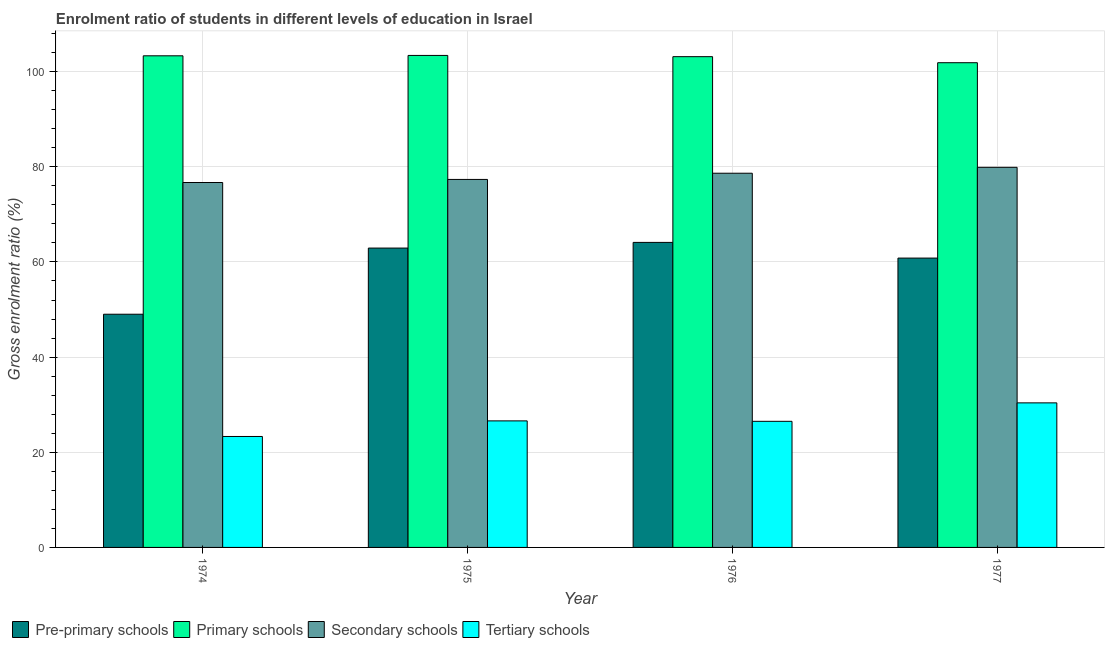Are the number of bars per tick equal to the number of legend labels?
Offer a very short reply. Yes. How many bars are there on the 2nd tick from the left?
Your answer should be compact. 4. How many bars are there on the 1st tick from the right?
Your answer should be very brief. 4. What is the label of the 4th group of bars from the left?
Give a very brief answer. 1977. What is the gross enrolment ratio in tertiary schools in 1975?
Your answer should be very brief. 26.6. Across all years, what is the maximum gross enrolment ratio in pre-primary schools?
Provide a short and direct response. 64.11. Across all years, what is the minimum gross enrolment ratio in secondary schools?
Your response must be concise. 76.7. In which year was the gross enrolment ratio in primary schools maximum?
Provide a short and direct response. 1975. In which year was the gross enrolment ratio in primary schools minimum?
Give a very brief answer. 1977. What is the total gross enrolment ratio in primary schools in the graph?
Your answer should be very brief. 411.76. What is the difference between the gross enrolment ratio in tertiary schools in 1976 and that in 1977?
Make the answer very short. -3.88. What is the difference between the gross enrolment ratio in pre-primary schools in 1976 and the gross enrolment ratio in tertiary schools in 1975?
Give a very brief answer. 1.19. What is the average gross enrolment ratio in tertiary schools per year?
Ensure brevity in your answer.  26.7. In the year 1977, what is the difference between the gross enrolment ratio in secondary schools and gross enrolment ratio in tertiary schools?
Make the answer very short. 0. What is the ratio of the gross enrolment ratio in pre-primary schools in 1974 to that in 1977?
Provide a succinct answer. 0.81. What is the difference between the highest and the second highest gross enrolment ratio in secondary schools?
Your answer should be compact. 1.24. What is the difference between the highest and the lowest gross enrolment ratio in primary schools?
Provide a succinct answer. 1.53. In how many years, is the gross enrolment ratio in primary schools greater than the average gross enrolment ratio in primary schools taken over all years?
Your response must be concise. 3. Is it the case that in every year, the sum of the gross enrolment ratio in tertiary schools and gross enrolment ratio in secondary schools is greater than the sum of gross enrolment ratio in pre-primary schools and gross enrolment ratio in primary schools?
Give a very brief answer. No. What does the 3rd bar from the left in 1974 represents?
Give a very brief answer. Secondary schools. What does the 4th bar from the right in 1977 represents?
Provide a short and direct response. Pre-primary schools. How many years are there in the graph?
Offer a terse response. 4. What is the difference between two consecutive major ticks on the Y-axis?
Offer a very short reply. 20. Are the values on the major ticks of Y-axis written in scientific E-notation?
Your response must be concise. No. Does the graph contain grids?
Keep it short and to the point. Yes. How many legend labels are there?
Your response must be concise. 4. What is the title of the graph?
Your response must be concise. Enrolment ratio of students in different levels of education in Israel. What is the label or title of the X-axis?
Make the answer very short. Year. What is the label or title of the Y-axis?
Make the answer very short. Gross enrolment ratio (%). What is the Gross enrolment ratio (%) in Pre-primary schools in 1974?
Give a very brief answer. 49.01. What is the Gross enrolment ratio (%) in Primary schools in 1974?
Your answer should be compact. 103.33. What is the Gross enrolment ratio (%) in Secondary schools in 1974?
Ensure brevity in your answer.  76.7. What is the Gross enrolment ratio (%) of Tertiary schools in 1974?
Offer a terse response. 23.32. What is the Gross enrolment ratio (%) in Pre-primary schools in 1975?
Provide a succinct answer. 62.92. What is the Gross enrolment ratio (%) of Primary schools in 1975?
Your answer should be very brief. 103.41. What is the Gross enrolment ratio (%) in Secondary schools in 1975?
Make the answer very short. 77.34. What is the Gross enrolment ratio (%) of Tertiary schools in 1975?
Your response must be concise. 26.6. What is the Gross enrolment ratio (%) in Pre-primary schools in 1976?
Your answer should be very brief. 64.11. What is the Gross enrolment ratio (%) of Primary schools in 1976?
Offer a terse response. 103.15. What is the Gross enrolment ratio (%) in Secondary schools in 1976?
Offer a very short reply. 78.65. What is the Gross enrolment ratio (%) in Tertiary schools in 1976?
Give a very brief answer. 26.5. What is the Gross enrolment ratio (%) in Pre-primary schools in 1977?
Ensure brevity in your answer.  60.81. What is the Gross enrolment ratio (%) of Primary schools in 1977?
Ensure brevity in your answer.  101.88. What is the Gross enrolment ratio (%) in Secondary schools in 1977?
Provide a short and direct response. 79.89. What is the Gross enrolment ratio (%) in Tertiary schools in 1977?
Provide a short and direct response. 30.38. Across all years, what is the maximum Gross enrolment ratio (%) of Pre-primary schools?
Ensure brevity in your answer.  64.11. Across all years, what is the maximum Gross enrolment ratio (%) in Primary schools?
Keep it short and to the point. 103.41. Across all years, what is the maximum Gross enrolment ratio (%) in Secondary schools?
Offer a very short reply. 79.89. Across all years, what is the maximum Gross enrolment ratio (%) of Tertiary schools?
Your answer should be compact. 30.38. Across all years, what is the minimum Gross enrolment ratio (%) of Pre-primary schools?
Your answer should be compact. 49.01. Across all years, what is the minimum Gross enrolment ratio (%) in Primary schools?
Keep it short and to the point. 101.88. Across all years, what is the minimum Gross enrolment ratio (%) in Secondary schools?
Provide a succinct answer. 76.7. Across all years, what is the minimum Gross enrolment ratio (%) of Tertiary schools?
Your answer should be very brief. 23.32. What is the total Gross enrolment ratio (%) of Pre-primary schools in the graph?
Keep it short and to the point. 236.86. What is the total Gross enrolment ratio (%) of Primary schools in the graph?
Make the answer very short. 411.76. What is the total Gross enrolment ratio (%) of Secondary schools in the graph?
Keep it short and to the point. 312.58. What is the total Gross enrolment ratio (%) of Tertiary schools in the graph?
Your response must be concise. 106.8. What is the difference between the Gross enrolment ratio (%) of Pre-primary schools in 1974 and that in 1975?
Your response must be concise. -13.91. What is the difference between the Gross enrolment ratio (%) in Primary schools in 1974 and that in 1975?
Offer a very short reply. -0.08. What is the difference between the Gross enrolment ratio (%) of Secondary schools in 1974 and that in 1975?
Provide a succinct answer. -0.65. What is the difference between the Gross enrolment ratio (%) of Tertiary schools in 1974 and that in 1975?
Your response must be concise. -3.28. What is the difference between the Gross enrolment ratio (%) in Pre-primary schools in 1974 and that in 1976?
Ensure brevity in your answer.  -15.1. What is the difference between the Gross enrolment ratio (%) in Primary schools in 1974 and that in 1976?
Your answer should be compact. 0.18. What is the difference between the Gross enrolment ratio (%) of Secondary schools in 1974 and that in 1976?
Give a very brief answer. -1.95. What is the difference between the Gross enrolment ratio (%) of Tertiary schools in 1974 and that in 1976?
Offer a terse response. -3.18. What is the difference between the Gross enrolment ratio (%) in Pre-primary schools in 1974 and that in 1977?
Ensure brevity in your answer.  -11.8. What is the difference between the Gross enrolment ratio (%) of Primary schools in 1974 and that in 1977?
Give a very brief answer. 1.45. What is the difference between the Gross enrolment ratio (%) in Secondary schools in 1974 and that in 1977?
Offer a terse response. -3.19. What is the difference between the Gross enrolment ratio (%) of Tertiary schools in 1974 and that in 1977?
Make the answer very short. -7.06. What is the difference between the Gross enrolment ratio (%) in Pre-primary schools in 1975 and that in 1976?
Offer a terse response. -1.19. What is the difference between the Gross enrolment ratio (%) of Primary schools in 1975 and that in 1976?
Give a very brief answer. 0.26. What is the difference between the Gross enrolment ratio (%) of Secondary schools in 1975 and that in 1976?
Ensure brevity in your answer.  -1.3. What is the difference between the Gross enrolment ratio (%) of Tertiary schools in 1975 and that in 1976?
Keep it short and to the point. 0.09. What is the difference between the Gross enrolment ratio (%) in Pre-primary schools in 1975 and that in 1977?
Your response must be concise. 2.11. What is the difference between the Gross enrolment ratio (%) of Primary schools in 1975 and that in 1977?
Keep it short and to the point. 1.53. What is the difference between the Gross enrolment ratio (%) of Secondary schools in 1975 and that in 1977?
Provide a succinct answer. -2.55. What is the difference between the Gross enrolment ratio (%) of Tertiary schools in 1975 and that in 1977?
Offer a terse response. -3.79. What is the difference between the Gross enrolment ratio (%) of Pre-primary schools in 1976 and that in 1977?
Offer a terse response. 3.3. What is the difference between the Gross enrolment ratio (%) of Primary schools in 1976 and that in 1977?
Offer a terse response. 1.27. What is the difference between the Gross enrolment ratio (%) of Secondary schools in 1976 and that in 1977?
Your answer should be compact. -1.24. What is the difference between the Gross enrolment ratio (%) in Tertiary schools in 1976 and that in 1977?
Provide a short and direct response. -3.88. What is the difference between the Gross enrolment ratio (%) of Pre-primary schools in 1974 and the Gross enrolment ratio (%) of Primary schools in 1975?
Offer a terse response. -54.4. What is the difference between the Gross enrolment ratio (%) of Pre-primary schools in 1974 and the Gross enrolment ratio (%) of Secondary schools in 1975?
Offer a very short reply. -28.33. What is the difference between the Gross enrolment ratio (%) of Pre-primary schools in 1974 and the Gross enrolment ratio (%) of Tertiary schools in 1975?
Make the answer very short. 22.42. What is the difference between the Gross enrolment ratio (%) of Primary schools in 1974 and the Gross enrolment ratio (%) of Secondary schools in 1975?
Your answer should be very brief. 25.98. What is the difference between the Gross enrolment ratio (%) of Primary schools in 1974 and the Gross enrolment ratio (%) of Tertiary schools in 1975?
Keep it short and to the point. 76.73. What is the difference between the Gross enrolment ratio (%) of Secondary schools in 1974 and the Gross enrolment ratio (%) of Tertiary schools in 1975?
Provide a short and direct response. 50.1. What is the difference between the Gross enrolment ratio (%) of Pre-primary schools in 1974 and the Gross enrolment ratio (%) of Primary schools in 1976?
Make the answer very short. -54.13. What is the difference between the Gross enrolment ratio (%) of Pre-primary schools in 1974 and the Gross enrolment ratio (%) of Secondary schools in 1976?
Offer a terse response. -29.64. What is the difference between the Gross enrolment ratio (%) in Pre-primary schools in 1974 and the Gross enrolment ratio (%) in Tertiary schools in 1976?
Give a very brief answer. 22.51. What is the difference between the Gross enrolment ratio (%) in Primary schools in 1974 and the Gross enrolment ratio (%) in Secondary schools in 1976?
Your response must be concise. 24.68. What is the difference between the Gross enrolment ratio (%) in Primary schools in 1974 and the Gross enrolment ratio (%) in Tertiary schools in 1976?
Your response must be concise. 76.83. What is the difference between the Gross enrolment ratio (%) of Secondary schools in 1974 and the Gross enrolment ratio (%) of Tertiary schools in 1976?
Give a very brief answer. 50.19. What is the difference between the Gross enrolment ratio (%) in Pre-primary schools in 1974 and the Gross enrolment ratio (%) in Primary schools in 1977?
Offer a terse response. -52.86. What is the difference between the Gross enrolment ratio (%) in Pre-primary schools in 1974 and the Gross enrolment ratio (%) in Secondary schools in 1977?
Your response must be concise. -30.88. What is the difference between the Gross enrolment ratio (%) of Pre-primary schools in 1974 and the Gross enrolment ratio (%) of Tertiary schools in 1977?
Provide a short and direct response. 18.63. What is the difference between the Gross enrolment ratio (%) of Primary schools in 1974 and the Gross enrolment ratio (%) of Secondary schools in 1977?
Ensure brevity in your answer.  23.44. What is the difference between the Gross enrolment ratio (%) of Primary schools in 1974 and the Gross enrolment ratio (%) of Tertiary schools in 1977?
Your answer should be very brief. 72.94. What is the difference between the Gross enrolment ratio (%) in Secondary schools in 1974 and the Gross enrolment ratio (%) in Tertiary schools in 1977?
Your answer should be compact. 46.31. What is the difference between the Gross enrolment ratio (%) of Pre-primary schools in 1975 and the Gross enrolment ratio (%) of Primary schools in 1976?
Provide a succinct answer. -40.23. What is the difference between the Gross enrolment ratio (%) in Pre-primary schools in 1975 and the Gross enrolment ratio (%) in Secondary schools in 1976?
Your answer should be compact. -15.73. What is the difference between the Gross enrolment ratio (%) in Pre-primary schools in 1975 and the Gross enrolment ratio (%) in Tertiary schools in 1976?
Offer a terse response. 36.42. What is the difference between the Gross enrolment ratio (%) in Primary schools in 1975 and the Gross enrolment ratio (%) in Secondary schools in 1976?
Provide a succinct answer. 24.76. What is the difference between the Gross enrolment ratio (%) of Primary schools in 1975 and the Gross enrolment ratio (%) of Tertiary schools in 1976?
Ensure brevity in your answer.  76.91. What is the difference between the Gross enrolment ratio (%) of Secondary schools in 1975 and the Gross enrolment ratio (%) of Tertiary schools in 1976?
Your response must be concise. 50.84. What is the difference between the Gross enrolment ratio (%) in Pre-primary schools in 1975 and the Gross enrolment ratio (%) in Primary schools in 1977?
Keep it short and to the point. -38.96. What is the difference between the Gross enrolment ratio (%) in Pre-primary schools in 1975 and the Gross enrolment ratio (%) in Secondary schools in 1977?
Keep it short and to the point. -16.97. What is the difference between the Gross enrolment ratio (%) of Pre-primary schools in 1975 and the Gross enrolment ratio (%) of Tertiary schools in 1977?
Your answer should be very brief. 32.54. What is the difference between the Gross enrolment ratio (%) of Primary schools in 1975 and the Gross enrolment ratio (%) of Secondary schools in 1977?
Your answer should be compact. 23.52. What is the difference between the Gross enrolment ratio (%) of Primary schools in 1975 and the Gross enrolment ratio (%) of Tertiary schools in 1977?
Keep it short and to the point. 73.02. What is the difference between the Gross enrolment ratio (%) of Secondary schools in 1975 and the Gross enrolment ratio (%) of Tertiary schools in 1977?
Offer a very short reply. 46.96. What is the difference between the Gross enrolment ratio (%) in Pre-primary schools in 1976 and the Gross enrolment ratio (%) in Primary schools in 1977?
Your answer should be compact. -37.77. What is the difference between the Gross enrolment ratio (%) of Pre-primary schools in 1976 and the Gross enrolment ratio (%) of Secondary schools in 1977?
Your response must be concise. -15.78. What is the difference between the Gross enrolment ratio (%) in Pre-primary schools in 1976 and the Gross enrolment ratio (%) in Tertiary schools in 1977?
Provide a succinct answer. 33.73. What is the difference between the Gross enrolment ratio (%) of Primary schools in 1976 and the Gross enrolment ratio (%) of Secondary schools in 1977?
Your response must be concise. 23.26. What is the difference between the Gross enrolment ratio (%) in Primary schools in 1976 and the Gross enrolment ratio (%) in Tertiary schools in 1977?
Provide a short and direct response. 72.76. What is the difference between the Gross enrolment ratio (%) in Secondary schools in 1976 and the Gross enrolment ratio (%) in Tertiary schools in 1977?
Your response must be concise. 48.27. What is the average Gross enrolment ratio (%) of Pre-primary schools per year?
Offer a very short reply. 59.21. What is the average Gross enrolment ratio (%) of Primary schools per year?
Your answer should be very brief. 102.94. What is the average Gross enrolment ratio (%) of Secondary schools per year?
Provide a succinct answer. 78.15. What is the average Gross enrolment ratio (%) of Tertiary schools per year?
Your answer should be very brief. 26.7. In the year 1974, what is the difference between the Gross enrolment ratio (%) in Pre-primary schools and Gross enrolment ratio (%) in Primary schools?
Offer a terse response. -54.31. In the year 1974, what is the difference between the Gross enrolment ratio (%) in Pre-primary schools and Gross enrolment ratio (%) in Secondary schools?
Keep it short and to the point. -27.68. In the year 1974, what is the difference between the Gross enrolment ratio (%) of Pre-primary schools and Gross enrolment ratio (%) of Tertiary schools?
Provide a short and direct response. 25.69. In the year 1974, what is the difference between the Gross enrolment ratio (%) in Primary schools and Gross enrolment ratio (%) in Secondary schools?
Your response must be concise. 26.63. In the year 1974, what is the difference between the Gross enrolment ratio (%) in Primary schools and Gross enrolment ratio (%) in Tertiary schools?
Your answer should be compact. 80.01. In the year 1974, what is the difference between the Gross enrolment ratio (%) in Secondary schools and Gross enrolment ratio (%) in Tertiary schools?
Offer a very short reply. 53.38. In the year 1975, what is the difference between the Gross enrolment ratio (%) of Pre-primary schools and Gross enrolment ratio (%) of Primary schools?
Make the answer very short. -40.49. In the year 1975, what is the difference between the Gross enrolment ratio (%) of Pre-primary schools and Gross enrolment ratio (%) of Secondary schools?
Offer a very short reply. -14.42. In the year 1975, what is the difference between the Gross enrolment ratio (%) of Pre-primary schools and Gross enrolment ratio (%) of Tertiary schools?
Ensure brevity in your answer.  36.32. In the year 1975, what is the difference between the Gross enrolment ratio (%) of Primary schools and Gross enrolment ratio (%) of Secondary schools?
Your answer should be very brief. 26.06. In the year 1975, what is the difference between the Gross enrolment ratio (%) of Primary schools and Gross enrolment ratio (%) of Tertiary schools?
Provide a short and direct response. 76.81. In the year 1975, what is the difference between the Gross enrolment ratio (%) of Secondary schools and Gross enrolment ratio (%) of Tertiary schools?
Your answer should be very brief. 50.75. In the year 1976, what is the difference between the Gross enrolment ratio (%) in Pre-primary schools and Gross enrolment ratio (%) in Primary schools?
Offer a terse response. -39.04. In the year 1976, what is the difference between the Gross enrolment ratio (%) in Pre-primary schools and Gross enrolment ratio (%) in Secondary schools?
Your response must be concise. -14.54. In the year 1976, what is the difference between the Gross enrolment ratio (%) of Pre-primary schools and Gross enrolment ratio (%) of Tertiary schools?
Offer a terse response. 37.61. In the year 1976, what is the difference between the Gross enrolment ratio (%) in Primary schools and Gross enrolment ratio (%) in Secondary schools?
Give a very brief answer. 24.5. In the year 1976, what is the difference between the Gross enrolment ratio (%) in Primary schools and Gross enrolment ratio (%) in Tertiary schools?
Your answer should be compact. 76.64. In the year 1976, what is the difference between the Gross enrolment ratio (%) of Secondary schools and Gross enrolment ratio (%) of Tertiary schools?
Offer a terse response. 52.15. In the year 1977, what is the difference between the Gross enrolment ratio (%) in Pre-primary schools and Gross enrolment ratio (%) in Primary schools?
Your answer should be very brief. -41.07. In the year 1977, what is the difference between the Gross enrolment ratio (%) of Pre-primary schools and Gross enrolment ratio (%) of Secondary schools?
Offer a very short reply. -19.08. In the year 1977, what is the difference between the Gross enrolment ratio (%) of Pre-primary schools and Gross enrolment ratio (%) of Tertiary schools?
Provide a succinct answer. 30.43. In the year 1977, what is the difference between the Gross enrolment ratio (%) in Primary schools and Gross enrolment ratio (%) in Secondary schools?
Make the answer very short. 21.99. In the year 1977, what is the difference between the Gross enrolment ratio (%) of Primary schools and Gross enrolment ratio (%) of Tertiary schools?
Provide a succinct answer. 71.49. In the year 1977, what is the difference between the Gross enrolment ratio (%) in Secondary schools and Gross enrolment ratio (%) in Tertiary schools?
Provide a short and direct response. 49.51. What is the ratio of the Gross enrolment ratio (%) in Pre-primary schools in 1974 to that in 1975?
Offer a terse response. 0.78. What is the ratio of the Gross enrolment ratio (%) of Secondary schools in 1974 to that in 1975?
Ensure brevity in your answer.  0.99. What is the ratio of the Gross enrolment ratio (%) in Tertiary schools in 1974 to that in 1975?
Your response must be concise. 0.88. What is the ratio of the Gross enrolment ratio (%) of Pre-primary schools in 1974 to that in 1976?
Ensure brevity in your answer.  0.76. What is the ratio of the Gross enrolment ratio (%) of Primary schools in 1974 to that in 1976?
Offer a very short reply. 1. What is the ratio of the Gross enrolment ratio (%) of Secondary schools in 1974 to that in 1976?
Ensure brevity in your answer.  0.98. What is the ratio of the Gross enrolment ratio (%) of Tertiary schools in 1974 to that in 1976?
Your answer should be compact. 0.88. What is the ratio of the Gross enrolment ratio (%) in Pre-primary schools in 1974 to that in 1977?
Your response must be concise. 0.81. What is the ratio of the Gross enrolment ratio (%) of Primary schools in 1974 to that in 1977?
Provide a short and direct response. 1.01. What is the ratio of the Gross enrolment ratio (%) of Secondary schools in 1974 to that in 1977?
Ensure brevity in your answer.  0.96. What is the ratio of the Gross enrolment ratio (%) of Tertiary schools in 1974 to that in 1977?
Make the answer very short. 0.77. What is the ratio of the Gross enrolment ratio (%) of Pre-primary schools in 1975 to that in 1976?
Provide a short and direct response. 0.98. What is the ratio of the Gross enrolment ratio (%) of Secondary schools in 1975 to that in 1976?
Your answer should be very brief. 0.98. What is the ratio of the Gross enrolment ratio (%) of Pre-primary schools in 1975 to that in 1977?
Keep it short and to the point. 1.03. What is the ratio of the Gross enrolment ratio (%) in Primary schools in 1975 to that in 1977?
Make the answer very short. 1.01. What is the ratio of the Gross enrolment ratio (%) in Secondary schools in 1975 to that in 1977?
Give a very brief answer. 0.97. What is the ratio of the Gross enrolment ratio (%) in Tertiary schools in 1975 to that in 1977?
Ensure brevity in your answer.  0.88. What is the ratio of the Gross enrolment ratio (%) of Pre-primary schools in 1976 to that in 1977?
Offer a very short reply. 1.05. What is the ratio of the Gross enrolment ratio (%) of Primary schools in 1976 to that in 1977?
Your answer should be compact. 1.01. What is the ratio of the Gross enrolment ratio (%) in Secondary schools in 1976 to that in 1977?
Offer a very short reply. 0.98. What is the ratio of the Gross enrolment ratio (%) of Tertiary schools in 1976 to that in 1977?
Offer a very short reply. 0.87. What is the difference between the highest and the second highest Gross enrolment ratio (%) in Pre-primary schools?
Offer a very short reply. 1.19. What is the difference between the highest and the second highest Gross enrolment ratio (%) of Secondary schools?
Provide a short and direct response. 1.24. What is the difference between the highest and the second highest Gross enrolment ratio (%) of Tertiary schools?
Your response must be concise. 3.79. What is the difference between the highest and the lowest Gross enrolment ratio (%) of Pre-primary schools?
Offer a very short reply. 15.1. What is the difference between the highest and the lowest Gross enrolment ratio (%) of Primary schools?
Give a very brief answer. 1.53. What is the difference between the highest and the lowest Gross enrolment ratio (%) in Secondary schools?
Provide a succinct answer. 3.19. What is the difference between the highest and the lowest Gross enrolment ratio (%) in Tertiary schools?
Offer a terse response. 7.06. 